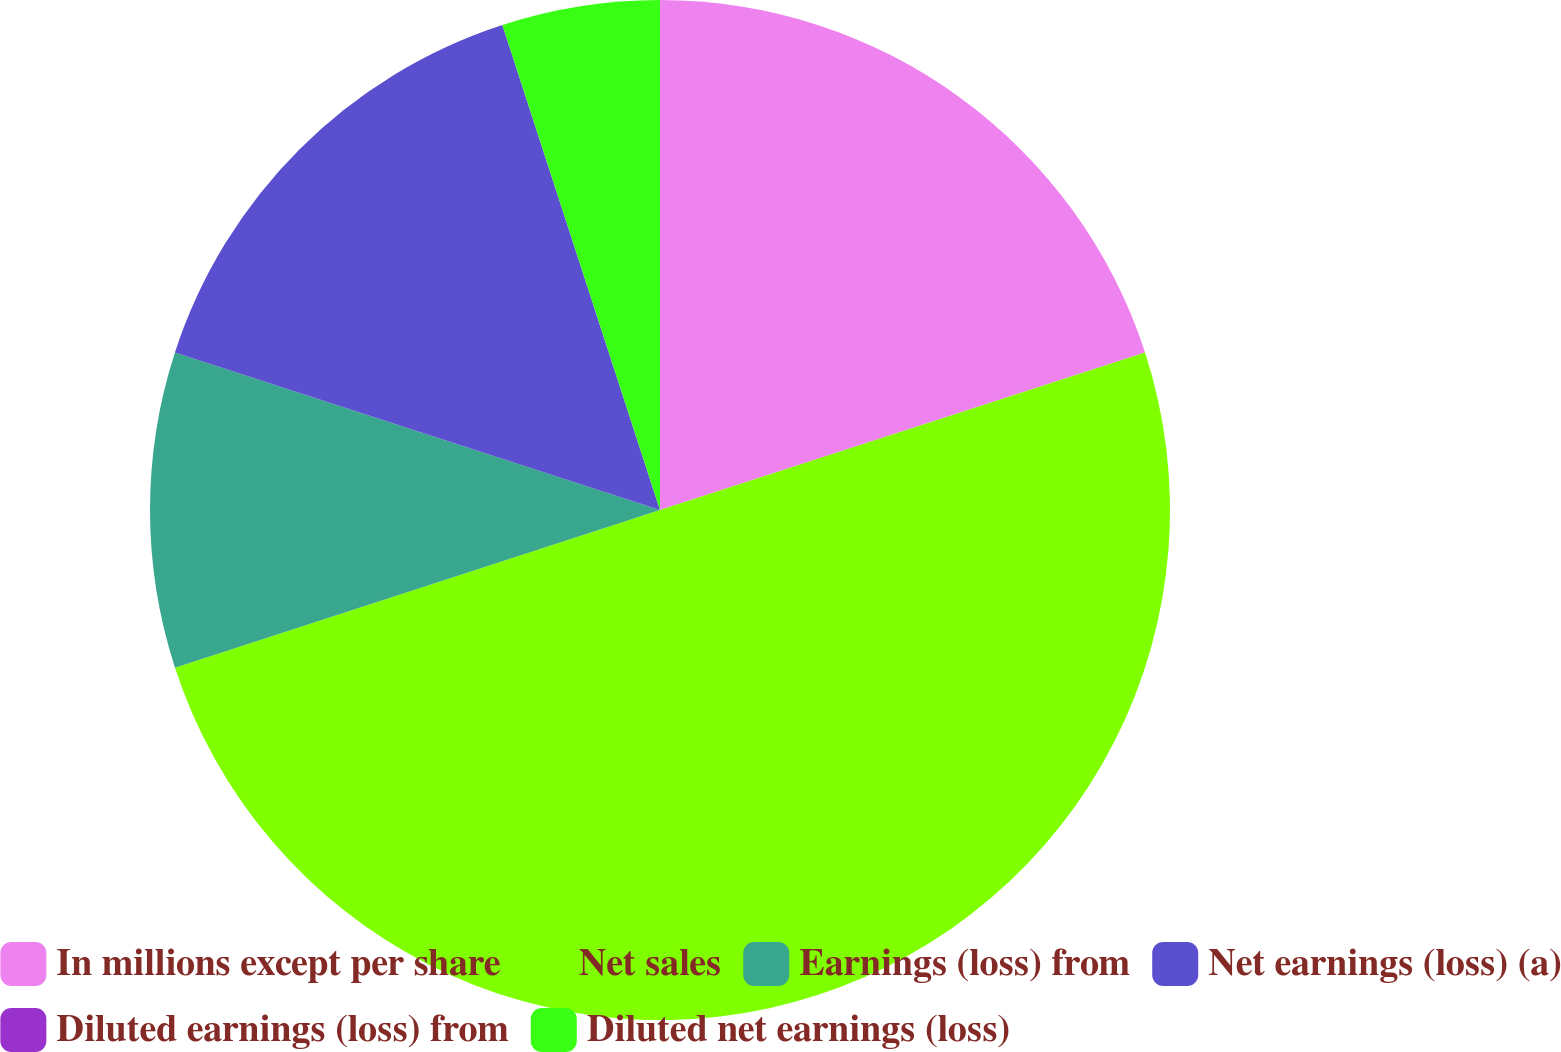Convert chart. <chart><loc_0><loc_0><loc_500><loc_500><pie_chart><fcel>In millions except per share<fcel>Net sales<fcel>Earnings (loss) from<fcel>Net earnings (loss) (a)<fcel>Diluted earnings (loss) from<fcel>Diluted net earnings (loss)<nl><fcel>20.0%<fcel>49.99%<fcel>10.0%<fcel>15.0%<fcel>0.0%<fcel>5.0%<nl></chart> 